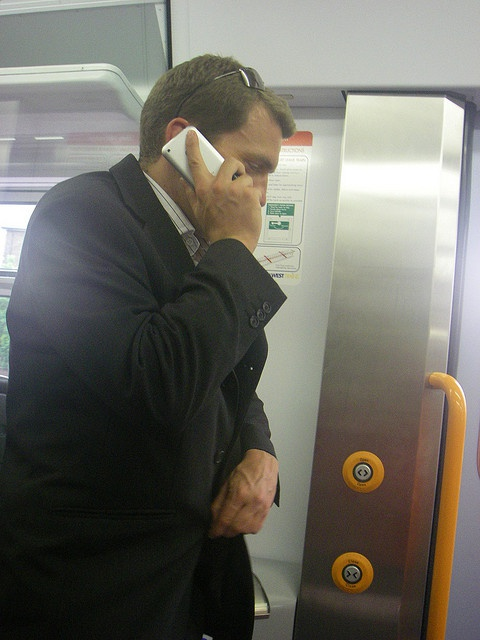Describe the objects in this image and their specific colors. I can see people in darkgray, black, gray, and tan tones and cell phone in darkgray, beige, and gray tones in this image. 